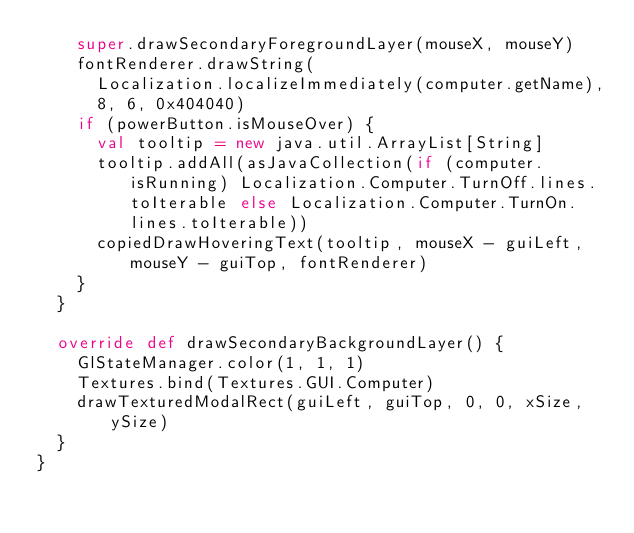Convert code to text. <code><loc_0><loc_0><loc_500><loc_500><_Scala_>    super.drawSecondaryForegroundLayer(mouseX, mouseY)
    fontRenderer.drawString(
      Localization.localizeImmediately(computer.getName),
      8, 6, 0x404040)
    if (powerButton.isMouseOver) {
      val tooltip = new java.util.ArrayList[String]
      tooltip.addAll(asJavaCollection(if (computer.isRunning) Localization.Computer.TurnOff.lines.toIterable else Localization.Computer.TurnOn.lines.toIterable))
      copiedDrawHoveringText(tooltip, mouseX - guiLeft, mouseY - guiTop, fontRenderer)
    }
  }

  override def drawSecondaryBackgroundLayer() {
    GlStateManager.color(1, 1, 1)
    Textures.bind(Textures.GUI.Computer)
    drawTexturedModalRect(guiLeft, guiTop, 0, 0, xSize, ySize)
  }
}
</code> 